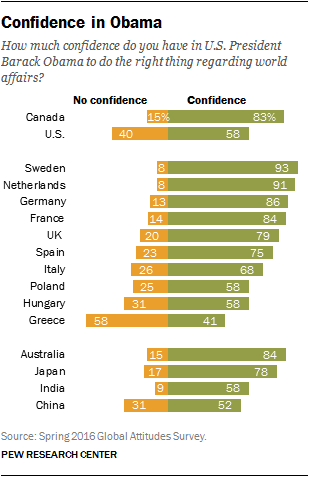Specify some key components in this picture. According to a recent survey, 83% of Canadians have confidence in President Obama. A significant number of countries have a proportion of individuals who lack confidence in President Obama, with 6 out of 10 or fewer countries meeting this criterion. 